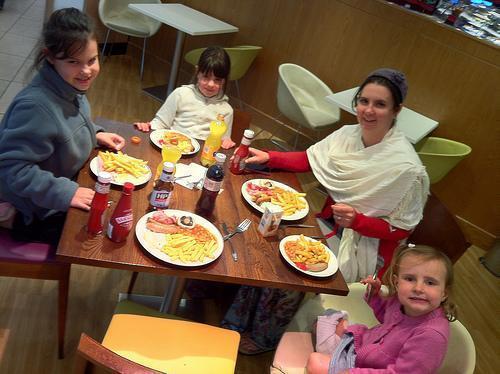How many people are in the photo?
Give a very brief answer. 4. How many people in the photo appear to be children?
Give a very brief answer. 3. 